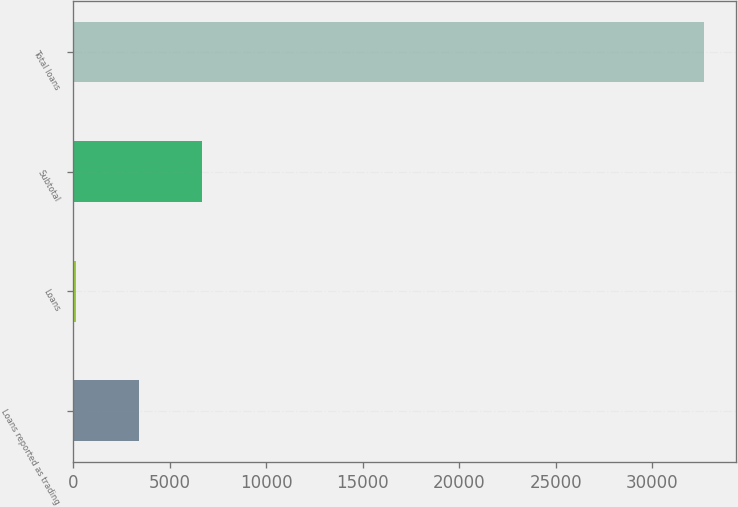Convert chart. <chart><loc_0><loc_0><loc_500><loc_500><bar_chart><fcel>Loans reported as trading<fcel>Loans<fcel>Subtotal<fcel>Total loans<nl><fcel>3405.8<fcel>151<fcel>6660.6<fcel>32699<nl></chart> 